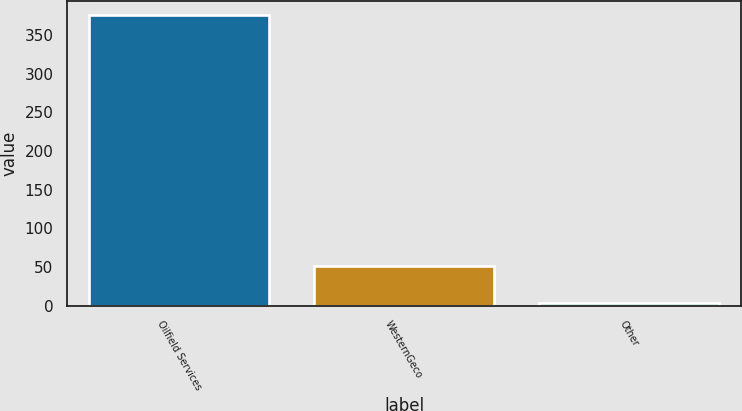Convert chart to OTSL. <chart><loc_0><loc_0><loc_500><loc_500><bar_chart><fcel>Oilfield Services<fcel>WesternGeco<fcel>Other<nl><fcel>375<fcel>52<fcel>4<nl></chart> 